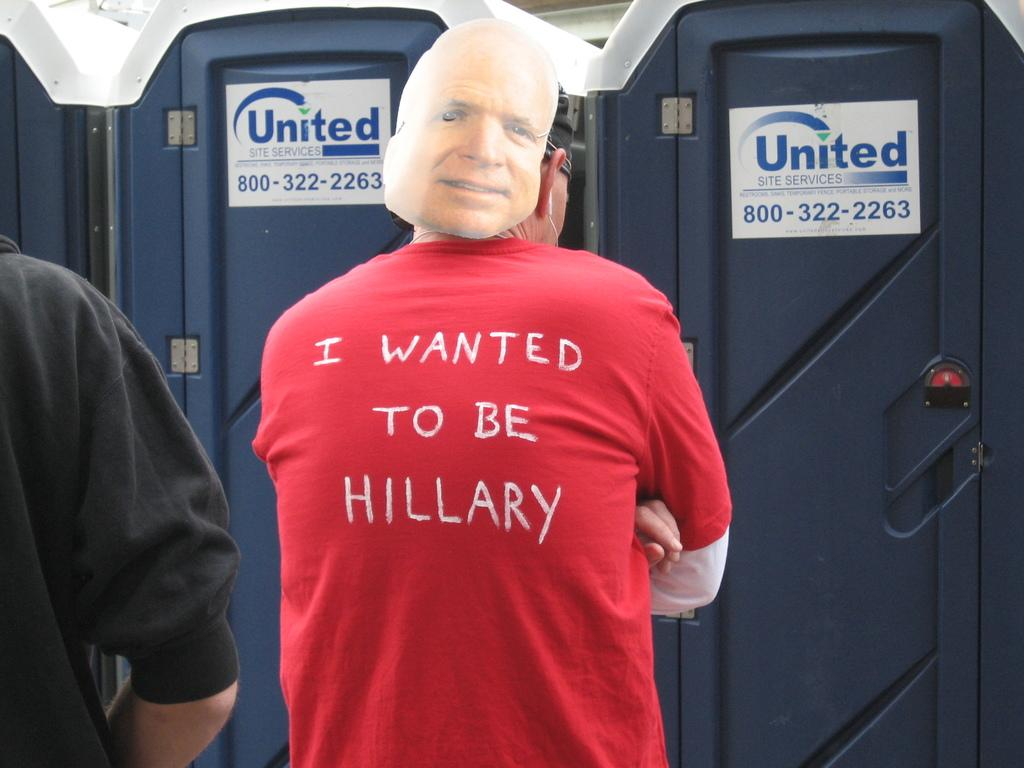<image>
Share a concise interpretation of the image provided. Someone is wearing a red t-shirt that says "I wanted to be Hillary" on the back. 